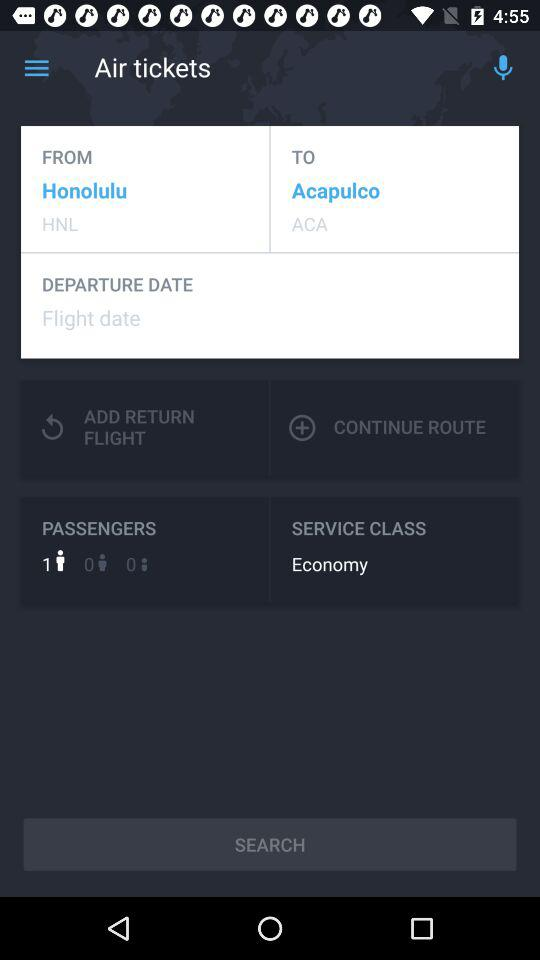How many passengers are there? There is 1 passenger. 